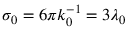Convert formula to latex. <formula><loc_0><loc_0><loc_500><loc_500>\sigma _ { 0 } = 6 \pi k _ { 0 } ^ { - 1 } = 3 \lambda _ { 0 }</formula> 